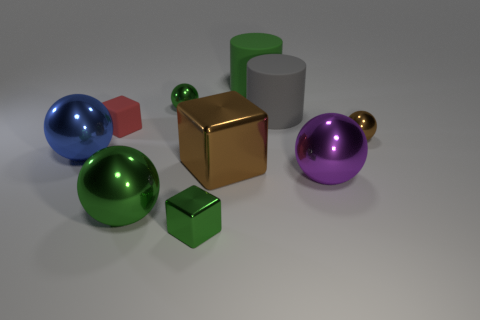What number of matte things are big gray spheres or large gray cylinders?
Offer a terse response. 1. The matte thing that is in front of the big gray cylinder has what shape?
Offer a very short reply. Cube. What size is the red object that is made of the same material as the large green cylinder?
Make the answer very short. Small. There is a tiny metallic object that is both to the left of the big brown object and behind the brown metal block; what shape is it?
Your answer should be compact. Sphere. Do the tiny metallic sphere that is on the right side of the green cube and the large shiny block have the same color?
Give a very brief answer. Yes. Does the green matte thing that is behind the large purple metal object have the same shape as the matte thing that is to the right of the big green rubber object?
Ensure brevity in your answer.  Yes. There is a green thing right of the tiny green cube; what is its size?
Ensure brevity in your answer.  Large. What size is the green thing that is right of the brown thing that is to the left of the small brown metal ball?
Ensure brevity in your answer.  Large. Are there more large cylinders than blocks?
Offer a very short reply. No. Are there more large green objects that are in front of the big metal block than big shiny objects behind the gray object?
Your response must be concise. Yes. 